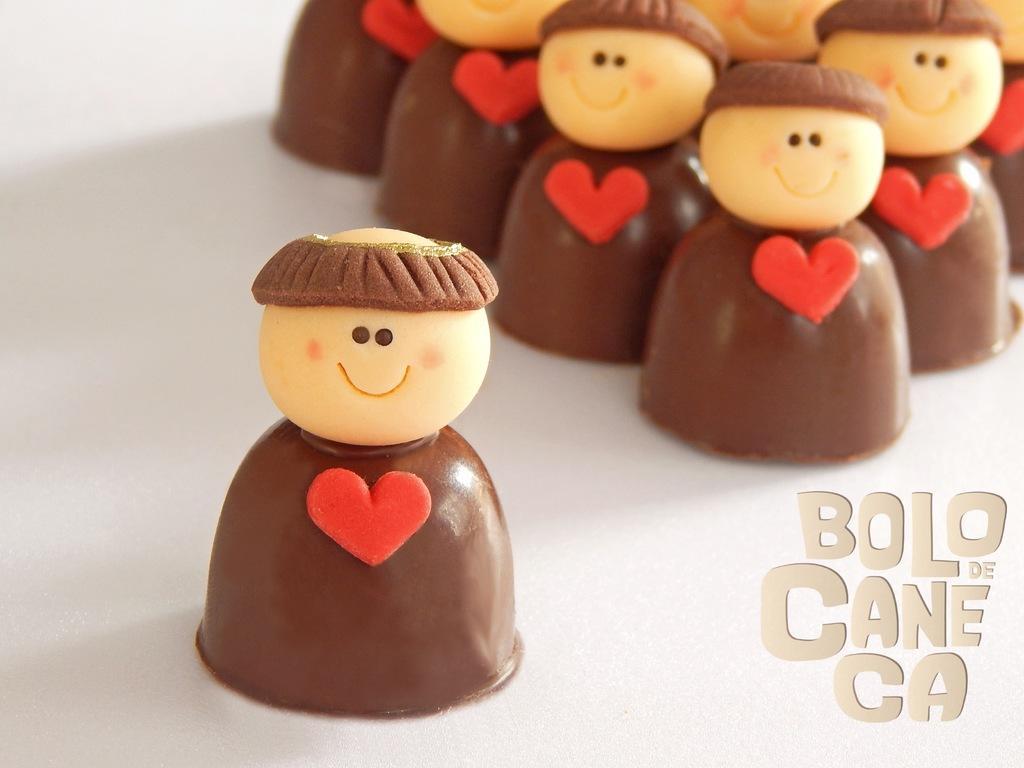Could you give a brief overview of what you see in this image? In this image I can see few chocolates in cream, red and brown color. They are on the white color surface and something is written on it. 